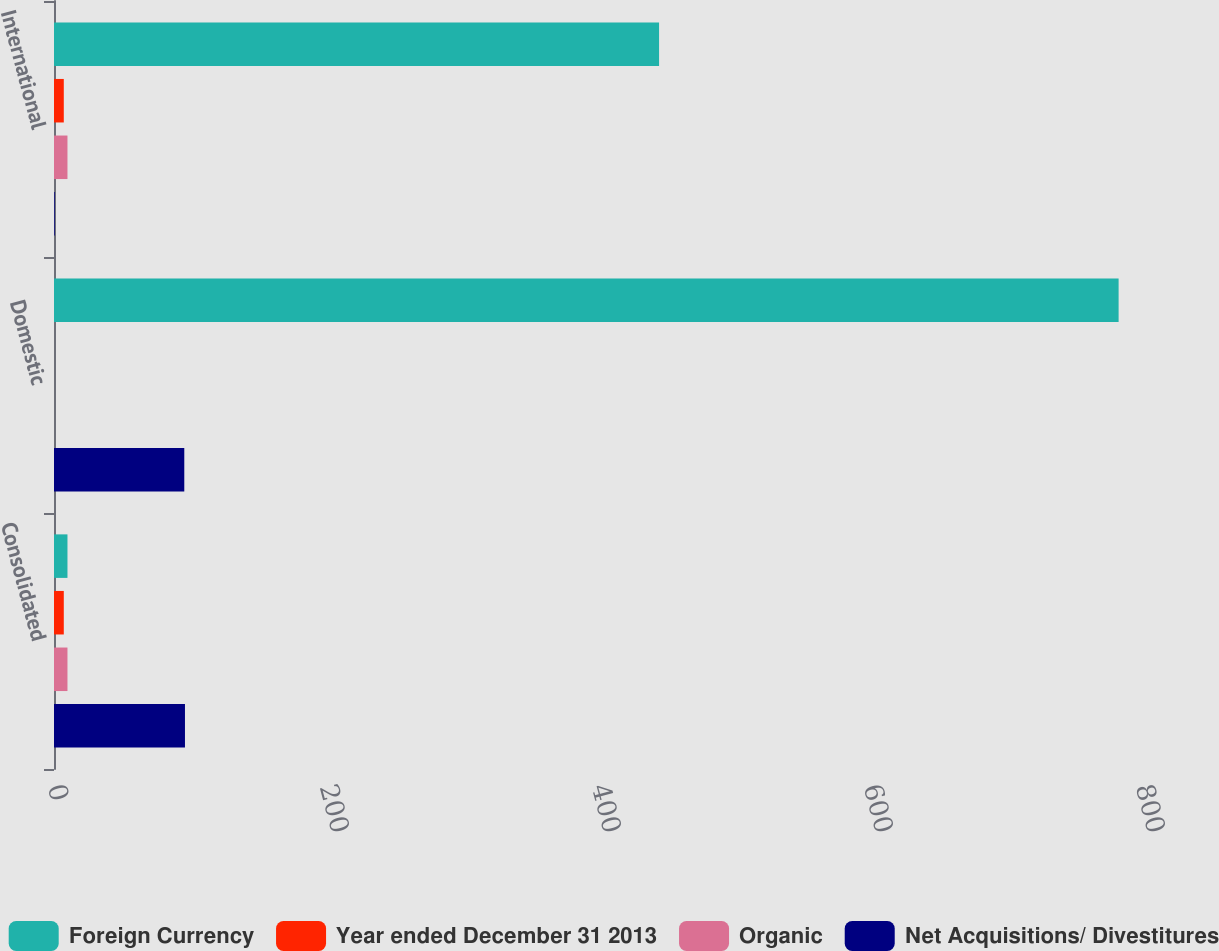Convert chart to OTSL. <chart><loc_0><loc_0><loc_500><loc_500><stacked_bar_chart><ecel><fcel>Consolidated<fcel>Domestic<fcel>International<nl><fcel>Foreign Currency<fcel>9.9<fcel>782.8<fcel>444.9<nl><fcel>Year ended December 31 2013<fcel>7.2<fcel>0<fcel>7.2<nl><fcel>Organic<fcel>9.9<fcel>0<fcel>9.9<nl><fcel>Net Acquisitions/ Divestitures<fcel>96.3<fcel>95.8<fcel>0.5<nl></chart> 